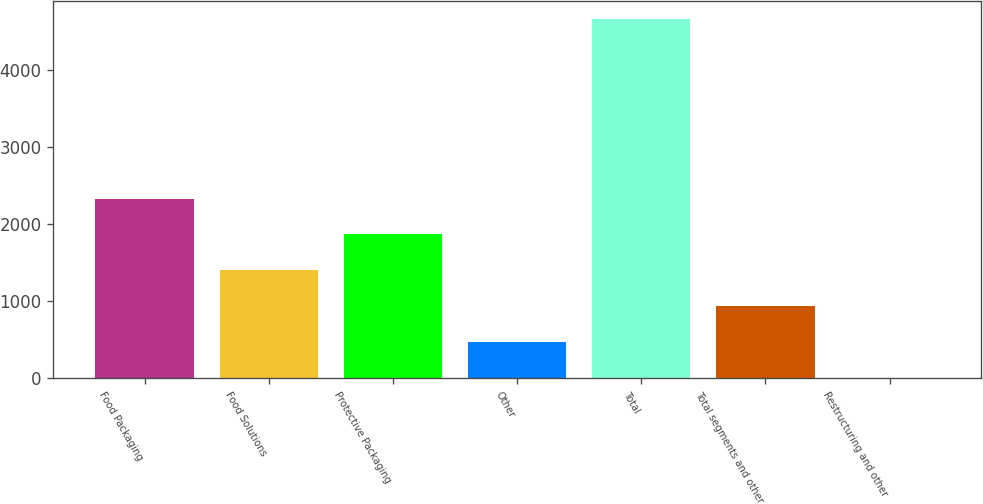Convert chart. <chart><loc_0><loc_0><loc_500><loc_500><bar_chart><fcel>Food Packaging<fcel>Food Solutions<fcel>Protective Packaging<fcel>Other<fcel>Total<fcel>Total segments and other<fcel>Restructuring and other<nl><fcel>2326.4<fcel>1396.48<fcel>1861.44<fcel>466.56<fcel>4651.2<fcel>931.52<fcel>1.6<nl></chart> 